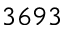<formula> <loc_0><loc_0><loc_500><loc_500>3 6 9 3</formula> 